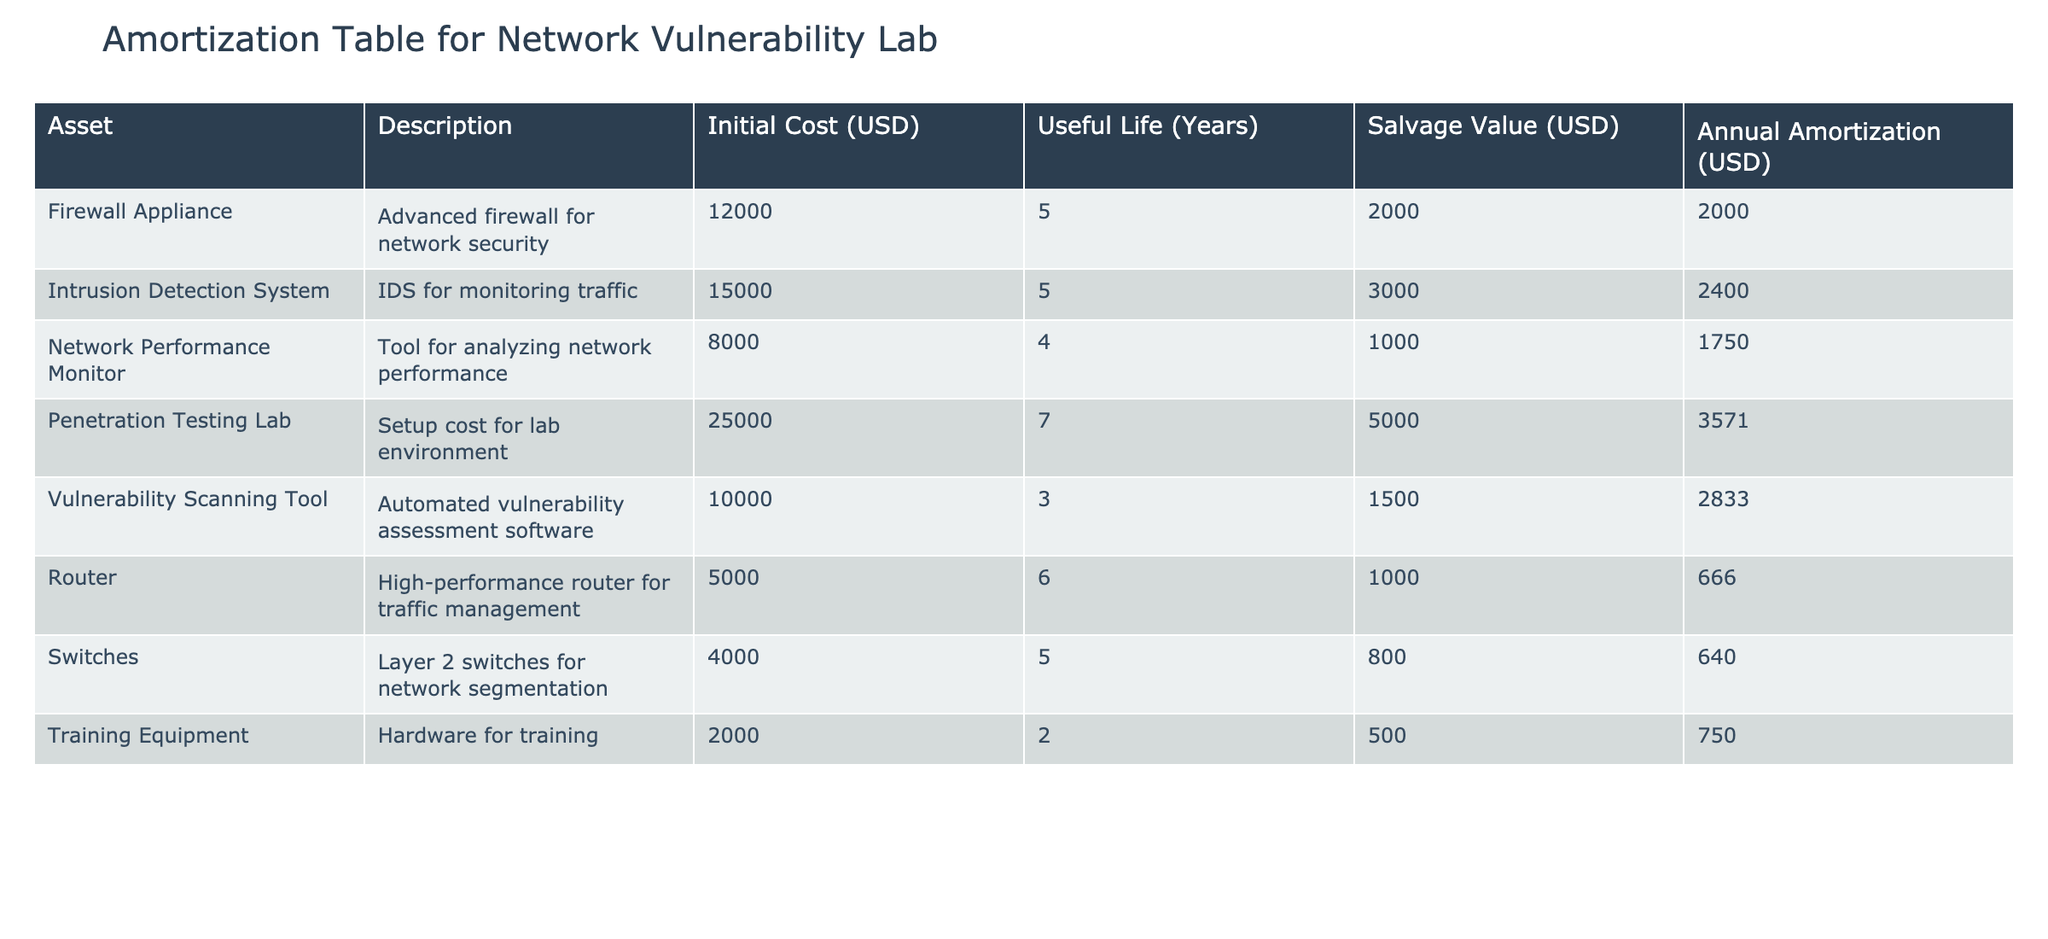What is the initial cost of the Intrusion Detection System? The table lists the Initial Cost (USD) for each asset. Looking for the row corresponding to the Intrusion Detection System, its Initial Cost is specified as 15000 USD.
Answer: 15000 USD What is the useful life of the Penetration Testing Lab setup? Each asset has a column that describes its Useful Life (Years). The Penetration Testing Lab is indicated to have a useful life of 7 years.
Answer: 7 years Which asset has the highest annual amortization? The Annual Amortization (USD) column needs to be examined to find the maximum value. The Firewall Appliance has an annual amortization of 2000 USD, while the Penetration Testing Lab has the highest annual amortization at 3571 USD.
Answer: Penetration Testing Lab What is the total initial cost of all the assets listed? To calculate the total initial cost, sum the Initial Cost of each asset: 12000 + 15000 + 8000 + 25000 + 10000 + 5000 + 4000 + 2000 = 83500 USD. The overall total is therefore 83500 USD.
Answer: 83500 USD Is the salvage value of the Network Performance Monitor greater than its annual amortization? The table indicates that the Salvage Value (USD) for the Network Performance Monitor is 1000 USD, and its Annual Amortization is 1750 USD. Since 1000 is less than 1750, the salvage value is not greater than the annual amortization.
Answer: No What is the average annual amortization across all assets? First, identify the Annual Amortization values: 2000, 2400, 1750, 3571, 2833, 666, 640, and 750, which sum to 15510. There are 8 assets, so the average is 15510 / 8 = 1938.75.
Answer: 1938.75 How much does the Training Equipment amortize each year compared to the average annual amortization? The annual amortization for Training Equipment is 750 USD. As calculated previously, the average annual amortization is 1938.75 USD. Thus, we see that 750 is substantially less than 1938.75.
Answer: Less than average What is the difference between the total useful life of all assets and the total salvage value? First, sum the Useful Life (Years): 5 + 5 + 4 + 7 + 3 + 6 + 5 + 2 = 37 years. Then sum the Salvage Values (USD): 2000 + 3000 + 1000 + 5000 + 1500 + 1000 + 800 + 500 = 13800 USD. The difference between the total useful life (interpreted as years and hence has a different unit and cannot be directly subtracted from a monetary sum) cannot be calculated meaningfully as they are not comparable quantities.
Answer: Not applicable Which asset has the lowest salvage value, and what is that value? Look at the Salvage Value (USD) column to find the minimum. The Training Equipment shows a salvage value of 500 USD, which is lower than all other listed salvage values.
Answer: Training Equipment, 500 USD 